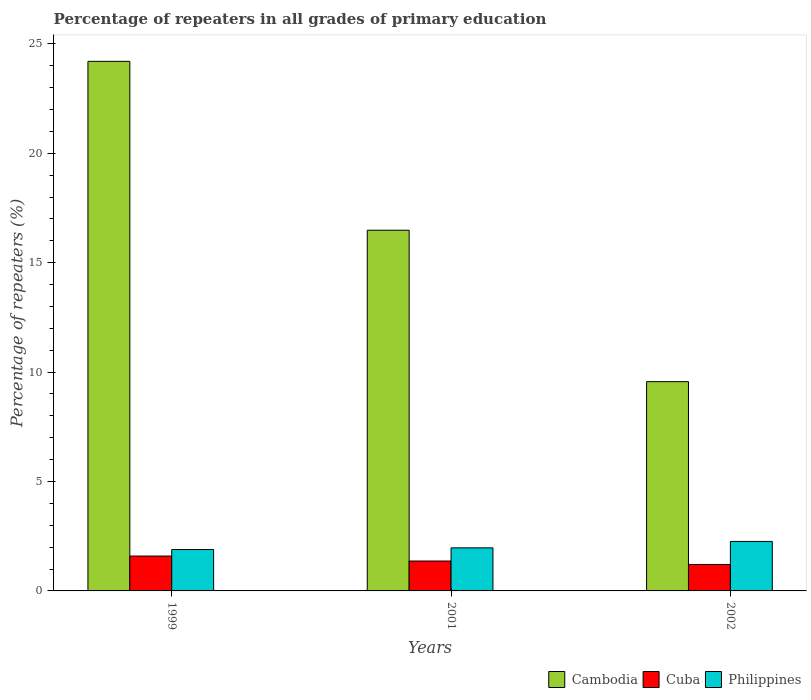Are the number of bars on each tick of the X-axis equal?
Offer a terse response. Yes. What is the label of the 1st group of bars from the left?
Provide a short and direct response. 1999. In how many cases, is the number of bars for a given year not equal to the number of legend labels?
Offer a terse response. 0. What is the percentage of repeaters in Philippines in 2002?
Your response must be concise. 2.26. Across all years, what is the maximum percentage of repeaters in Cuba?
Provide a short and direct response. 1.59. Across all years, what is the minimum percentage of repeaters in Cuba?
Provide a short and direct response. 1.21. In which year was the percentage of repeaters in Cuba minimum?
Your response must be concise. 2002. What is the total percentage of repeaters in Cambodia in the graph?
Offer a very short reply. 50.25. What is the difference between the percentage of repeaters in Cambodia in 1999 and that in 2002?
Your answer should be compact. 14.64. What is the difference between the percentage of repeaters in Cuba in 2002 and the percentage of repeaters in Philippines in 1999?
Offer a terse response. -0.68. What is the average percentage of repeaters in Philippines per year?
Keep it short and to the point. 2.04. In the year 2002, what is the difference between the percentage of repeaters in Philippines and percentage of repeaters in Cambodia?
Provide a succinct answer. -7.3. In how many years, is the percentage of repeaters in Philippines greater than 14 %?
Ensure brevity in your answer.  0. What is the ratio of the percentage of repeaters in Cambodia in 1999 to that in 2001?
Offer a very short reply. 1.47. Is the difference between the percentage of repeaters in Philippines in 1999 and 2002 greater than the difference between the percentage of repeaters in Cambodia in 1999 and 2002?
Your answer should be compact. No. What is the difference between the highest and the second highest percentage of repeaters in Cuba?
Offer a very short reply. 0.23. What is the difference between the highest and the lowest percentage of repeaters in Cambodia?
Make the answer very short. 14.64. What does the 2nd bar from the left in 1999 represents?
Provide a short and direct response. Cuba. What does the 1st bar from the right in 2002 represents?
Your response must be concise. Philippines. Is it the case that in every year, the sum of the percentage of repeaters in Cuba and percentage of repeaters in Cambodia is greater than the percentage of repeaters in Philippines?
Ensure brevity in your answer.  Yes. How many bars are there?
Offer a terse response. 9. How many years are there in the graph?
Provide a succinct answer. 3. What is the difference between two consecutive major ticks on the Y-axis?
Keep it short and to the point. 5. Does the graph contain grids?
Your answer should be compact. No. What is the title of the graph?
Your answer should be very brief. Percentage of repeaters in all grades of primary education. Does "Romania" appear as one of the legend labels in the graph?
Offer a terse response. No. What is the label or title of the Y-axis?
Keep it short and to the point. Percentage of repeaters (%). What is the Percentage of repeaters (%) in Cambodia in 1999?
Provide a short and direct response. 24.2. What is the Percentage of repeaters (%) in Cuba in 1999?
Your response must be concise. 1.59. What is the Percentage of repeaters (%) of Philippines in 1999?
Keep it short and to the point. 1.89. What is the Percentage of repeaters (%) in Cambodia in 2001?
Ensure brevity in your answer.  16.48. What is the Percentage of repeaters (%) in Cuba in 2001?
Offer a terse response. 1.37. What is the Percentage of repeaters (%) of Philippines in 2001?
Offer a terse response. 1.97. What is the Percentage of repeaters (%) in Cambodia in 2002?
Your response must be concise. 9.56. What is the Percentage of repeaters (%) in Cuba in 2002?
Provide a succinct answer. 1.21. What is the Percentage of repeaters (%) in Philippines in 2002?
Offer a very short reply. 2.26. Across all years, what is the maximum Percentage of repeaters (%) of Cambodia?
Your answer should be very brief. 24.2. Across all years, what is the maximum Percentage of repeaters (%) in Cuba?
Provide a short and direct response. 1.59. Across all years, what is the maximum Percentage of repeaters (%) in Philippines?
Your answer should be compact. 2.26. Across all years, what is the minimum Percentage of repeaters (%) in Cambodia?
Your answer should be very brief. 9.56. Across all years, what is the minimum Percentage of repeaters (%) in Cuba?
Provide a short and direct response. 1.21. Across all years, what is the minimum Percentage of repeaters (%) in Philippines?
Offer a very short reply. 1.89. What is the total Percentage of repeaters (%) in Cambodia in the graph?
Offer a terse response. 50.25. What is the total Percentage of repeaters (%) of Cuba in the graph?
Keep it short and to the point. 4.17. What is the total Percentage of repeaters (%) in Philippines in the graph?
Give a very brief answer. 6.12. What is the difference between the Percentage of repeaters (%) in Cambodia in 1999 and that in 2001?
Your answer should be very brief. 7.72. What is the difference between the Percentage of repeaters (%) of Cuba in 1999 and that in 2001?
Your answer should be compact. 0.23. What is the difference between the Percentage of repeaters (%) of Philippines in 1999 and that in 2001?
Give a very brief answer. -0.08. What is the difference between the Percentage of repeaters (%) in Cambodia in 1999 and that in 2002?
Your response must be concise. 14.64. What is the difference between the Percentage of repeaters (%) in Cuba in 1999 and that in 2002?
Your response must be concise. 0.38. What is the difference between the Percentage of repeaters (%) in Philippines in 1999 and that in 2002?
Your answer should be compact. -0.37. What is the difference between the Percentage of repeaters (%) of Cambodia in 2001 and that in 2002?
Offer a terse response. 6.92. What is the difference between the Percentage of repeaters (%) in Cuba in 2001 and that in 2002?
Make the answer very short. 0.16. What is the difference between the Percentage of repeaters (%) in Philippines in 2001 and that in 2002?
Offer a very short reply. -0.29. What is the difference between the Percentage of repeaters (%) in Cambodia in 1999 and the Percentage of repeaters (%) in Cuba in 2001?
Offer a very short reply. 22.84. What is the difference between the Percentage of repeaters (%) in Cambodia in 1999 and the Percentage of repeaters (%) in Philippines in 2001?
Provide a succinct answer. 22.23. What is the difference between the Percentage of repeaters (%) of Cuba in 1999 and the Percentage of repeaters (%) of Philippines in 2001?
Your answer should be compact. -0.37. What is the difference between the Percentage of repeaters (%) in Cambodia in 1999 and the Percentage of repeaters (%) in Cuba in 2002?
Your answer should be compact. 22.99. What is the difference between the Percentage of repeaters (%) of Cambodia in 1999 and the Percentage of repeaters (%) of Philippines in 2002?
Offer a very short reply. 21.94. What is the difference between the Percentage of repeaters (%) in Cuba in 1999 and the Percentage of repeaters (%) in Philippines in 2002?
Provide a succinct answer. -0.67. What is the difference between the Percentage of repeaters (%) of Cambodia in 2001 and the Percentage of repeaters (%) of Cuba in 2002?
Give a very brief answer. 15.27. What is the difference between the Percentage of repeaters (%) in Cambodia in 2001 and the Percentage of repeaters (%) in Philippines in 2002?
Provide a succinct answer. 14.22. What is the difference between the Percentage of repeaters (%) in Cuba in 2001 and the Percentage of repeaters (%) in Philippines in 2002?
Ensure brevity in your answer.  -0.9. What is the average Percentage of repeaters (%) in Cambodia per year?
Provide a short and direct response. 16.75. What is the average Percentage of repeaters (%) of Cuba per year?
Your answer should be very brief. 1.39. What is the average Percentage of repeaters (%) in Philippines per year?
Keep it short and to the point. 2.04. In the year 1999, what is the difference between the Percentage of repeaters (%) of Cambodia and Percentage of repeaters (%) of Cuba?
Your response must be concise. 22.61. In the year 1999, what is the difference between the Percentage of repeaters (%) of Cambodia and Percentage of repeaters (%) of Philippines?
Your answer should be compact. 22.31. In the year 1999, what is the difference between the Percentage of repeaters (%) of Cuba and Percentage of repeaters (%) of Philippines?
Make the answer very short. -0.3. In the year 2001, what is the difference between the Percentage of repeaters (%) in Cambodia and Percentage of repeaters (%) in Cuba?
Keep it short and to the point. 15.12. In the year 2001, what is the difference between the Percentage of repeaters (%) of Cambodia and Percentage of repeaters (%) of Philippines?
Your response must be concise. 14.52. In the year 2001, what is the difference between the Percentage of repeaters (%) in Cuba and Percentage of repeaters (%) in Philippines?
Provide a succinct answer. -0.6. In the year 2002, what is the difference between the Percentage of repeaters (%) of Cambodia and Percentage of repeaters (%) of Cuba?
Your answer should be compact. 8.35. In the year 2002, what is the difference between the Percentage of repeaters (%) in Cambodia and Percentage of repeaters (%) in Philippines?
Offer a terse response. 7.3. In the year 2002, what is the difference between the Percentage of repeaters (%) of Cuba and Percentage of repeaters (%) of Philippines?
Offer a very short reply. -1.05. What is the ratio of the Percentage of repeaters (%) of Cambodia in 1999 to that in 2001?
Give a very brief answer. 1.47. What is the ratio of the Percentage of repeaters (%) in Cuba in 1999 to that in 2001?
Your response must be concise. 1.17. What is the ratio of the Percentage of repeaters (%) of Philippines in 1999 to that in 2001?
Offer a very short reply. 0.96. What is the ratio of the Percentage of repeaters (%) in Cambodia in 1999 to that in 2002?
Offer a terse response. 2.53. What is the ratio of the Percentage of repeaters (%) in Cuba in 1999 to that in 2002?
Ensure brevity in your answer.  1.32. What is the ratio of the Percentage of repeaters (%) in Philippines in 1999 to that in 2002?
Keep it short and to the point. 0.84. What is the ratio of the Percentage of repeaters (%) of Cambodia in 2001 to that in 2002?
Keep it short and to the point. 1.72. What is the ratio of the Percentage of repeaters (%) of Cuba in 2001 to that in 2002?
Your answer should be very brief. 1.13. What is the ratio of the Percentage of repeaters (%) in Philippines in 2001 to that in 2002?
Give a very brief answer. 0.87. What is the difference between the highest and the second highest Percentage of repeaters (%) of Cambodia?
Keep it short and to the point. 7.72. What is the difference between the highest and the second highest Percentage of repeaters (%) of Cuba?
Provide a short and direct response. 0.23. What is the difference between the highest and the second highest Percentage of repeaters (%) of Philippines?
Offer a very short reply. 0.29. What is the difference between the highest and the lowest Percentage of repeaters (%) of Cambodia?
Make the answer very short. 14.64. What is the difference between the highest and the lowest Percentage of repeaters (%) of Cuba?
Keep it short and to the point. 0.38. What is the difference between the highest and the lowest Percentage of repeaters (%) in Philippines?
Ensure brevity in your answer.  0.37. 